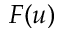Convert formula to latex. <formula><loc_0><loc_0><loc_500><loc_500>F ( u )</formula> 